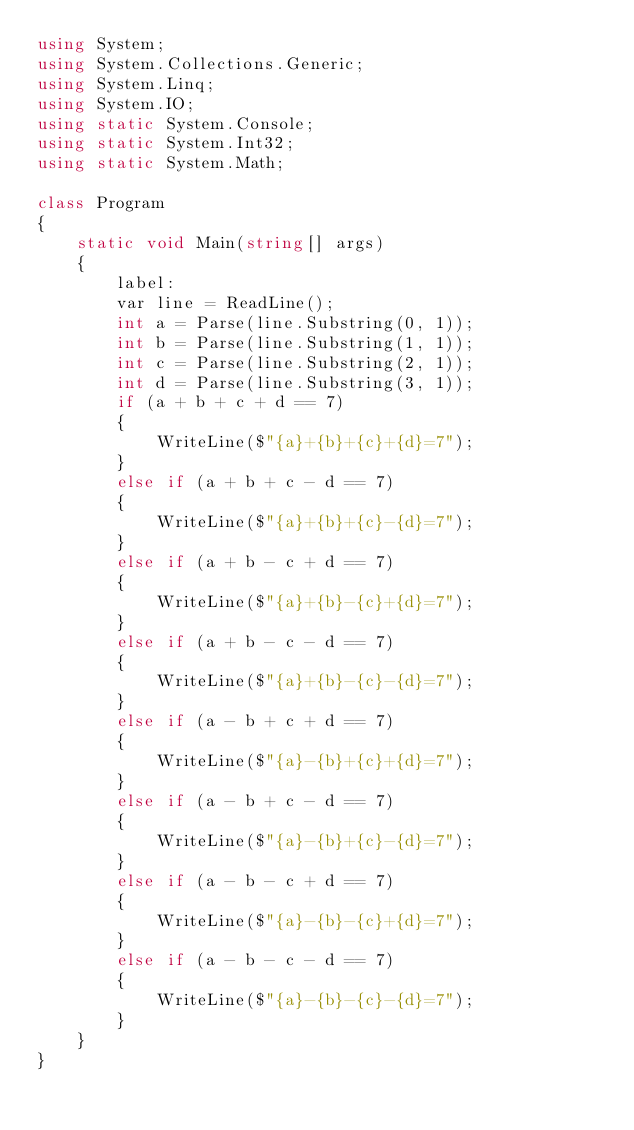Convert code to text. <code><loc_0><loc_0><loc_500><loc_500><_C#_>using System;
using System.Collections.Generic;
using System.Linq;
using System.IO;
using static System.Console;
using static System.Int32;
using static System.Math;
 
class Program
{
    static void Main(string[] args)
    {
        label:
        var line = ReadLine();
        int a = Parse(line.Substring(0, 1));
        int b = Parse(line.Substring(1, 1));
        int c = Parse(line.Substring(2, 1));
        int d = Parse(line.Substring(3, 1));
        if (a + b + c + d == 7)
        {
            WriteLine($"{a}+{b}+{c}+{d}=7");
        }
        else if (a + b + c - d == 7)
        {
            WriteLine($"{a}+{b}+{c}-{d}=7");
        }
        else if (a + b - c + d == 7)
        {
            WriteLine($"{a}+{b}-{c}+{d}=7");
        }
        else if (a + b - c - d == 7)
        {
            WriteLine($"{a}+{b}-{c}-{d}=7");
        }
        else if (a - b + c + d == 7)
        {
            WriteLine($"{a}-{b}+{c}+{d}=7");
        }
        else if (a - b + c - d == 7)
        {
            WriteLine($"{a}-{b}+{c}-{d}=7");
        }
        else if (a - b - c + d == 7)
        {
            WriteLine($"{a}-{b}-{c}+{d}=7");
        }
        else if (a - b - c - d == 7)
        {
            WriteLine($"{a}-{b}-{c}-{d}=7");
        }
    }
}
</code> 